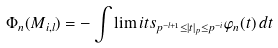<formula> <loc_0><loc_0><loc_500><loc_500>\Phi _ { n } ( M _ { i , l } ) = - \int \lim i t s _ { p ^ { - l + 1 } \leq | t | _ { p } \leq p ^ { - i } } \varphi _ { n } ( t ) \, d t</formula> 